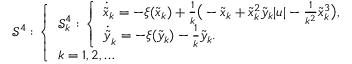Convert formula to latex. <formula><loc_0><loc_0><loc_500><loc_500>\begin{array} { r } { { \mathcal { S } } ^ { 4 } \colon \left \{ \begin{array} { l } { { \mathcal { S } } _ { k } ^ { 4 } \colon \left \{ \begin{array} { l } { \dot { \tilde { x } } _ { k } = - \xi ( \tilde { x } _ { k } ) + \frac { 1 } { k } \left ( - \tilde { x } _ { k } + \tilde { x } _ { k } ^ { 2 } \tilde { y } _ { k } | u | - \frac { 1 } { k ^ { 2 } } \tilde { x } _ { k } ^ { 3 } \right ) , } \\ { \dot { \tilde { y } } _ { k } = - \xi ( \tilde { y } _ { k } ) - \frac { 1 } { k } \tilde { y } _ { k } . } \end{array} } \\ { k = 1 , 2 , \dots } \end{array} } \end{array}</formula> 